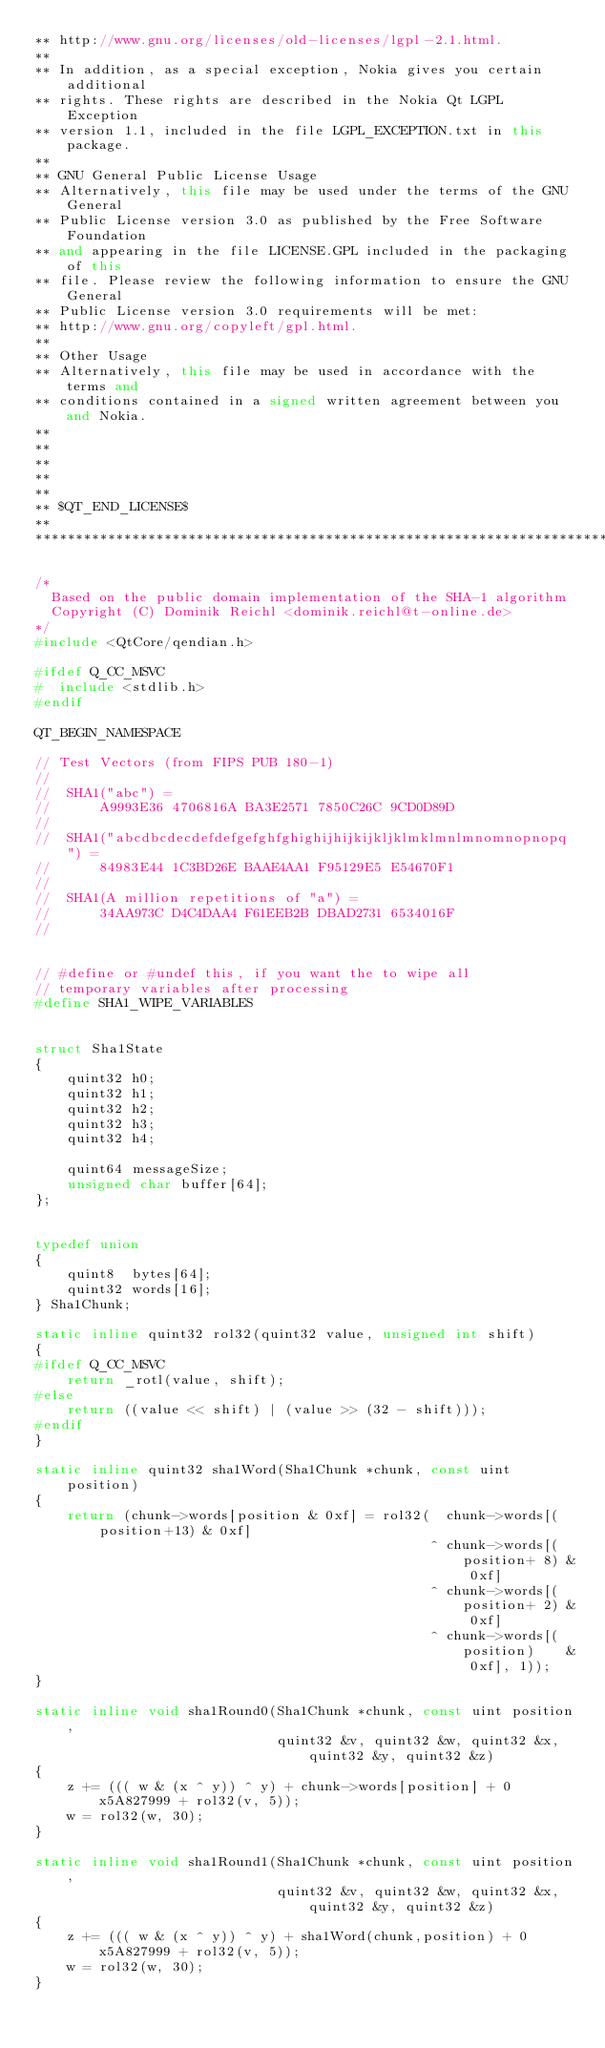<code> <loc_0><loc_0><loc_500><loc_500><_C++_>** http://www.gnu.org/licenses/old-licenses/lgpl-2.1.html.
**
** In addition, as a special exception, Nokia gives you certain additional
** rights. These rights are described in the Nokia Qt LGPL Exception
** version 1.1, included in the file LGPL_EXCEPTION.txt in this package.
**
** GNU General Public License Usage
** Alternatively, this file may be used under the terms of the GNU General
** Public License version 3.0 as published by the Free Software Foundation
** and appearing in the file LICENSE.GPL included in the packaging of this
** file. Please review the following information to ensure the GNU General
** Public License version 3.0 requirements will be met:
** http://www.gnu.org/copyleft/gpl.html.
**
** Other Usage
** Alternatively, this file may be used in accordance with the terms and
** conditions contained in a signed written agreement between you and Nokia.
**
**
**
**
**
** $QT_END_LICENSE$
**
****************************************************************************/

/*
  Based on the public domain implementation of the SHA-1 algorithm
  Copyright (C) Dominik Reichl <dominik.reichl@t-online.de>
*/
#include <QtCore/qendian.h>

#ifdef Q_CC_MSVC
#  include <stdlib.h>
#endif

QT_BEGIN_NAMESPACE

// Test Vectors (from FIPS PUB 180-1)
//
//  SHA1("abc") =
//      A9993E36 4706816A BA3E2571 7850C26C 9CD0D89D
//
//  SHA1("abcdbcdecdefdefgefghfghighijhijkijkljklmklmnlmnomnopnopq") =
//      84983E44 1C3BD26E BAAE4AA1 F95129E5 E54670F1
//
//  SHA1(A million repetitions of "a") =
//      34AA973C D4C4DAA4 F61EEB2B DBAD2731 6534016F
//


// #define or #undef this, if you want the to wipe all
// temporary variables after processing
#define SHA1_WIPE_VARIABLES


struct Sha1State
{
    quint32 h0;
    quint32 h1;
    quint32 h2;
    quint32 h3;
    quint32 h4;

    quint64 messageSize;
    unsigned char buffer[64];
};


typedef union
{
    quint8  bytes[64];
    quint32 words[16];
} Sha1Chunk;

static inline quint32 rol32(quint32 value, unsigned int shift)
{
#ifdef Q_CC_MSVC
    return _rotl(value, shift);
#else
    return ((value << shift) | (value >> (32 - shift)));
#endif
}

static inline quint32 sha1Word(Sha1Chunk *chunk, const uint position)
{
    return (chunk->words[position & 0xf] = rol32(  chunk->words[(position+13) & 0xf]
                                                 ^ chunk->words[(position+ 8) & 0xf]
                                                 ^ chunk->words[(position+ 2) & 0xf]
                                                 ^ chunk->words[(position)    & 0xf], 1));
}

static inline void sha1Round0(Sha1Chunk *chunk, const uint position,
                              quint32 &v, quint32 &w, quint32 &x, quint32 &y, quint32 &z)
{
    z += ((( w & (x ^ y)) ^ y) + chunk->words[position] + 0x5A827999 + rol32(v, 5));
    w = rol32(w, 30);
}

static inline void sha1Round1(Sha1Chunk *chunk, const uint position,
                              quint32 &v, quint32 &w, quint32 &x, quint32 &y, quint32 &z)
{
    z += ((( w & (x ^ y)) ^ y) + sha1Word(chunk,position) + 0x5A827999 + rol32(v, 5));
    w = rol32(w, 30);
}
</code> 